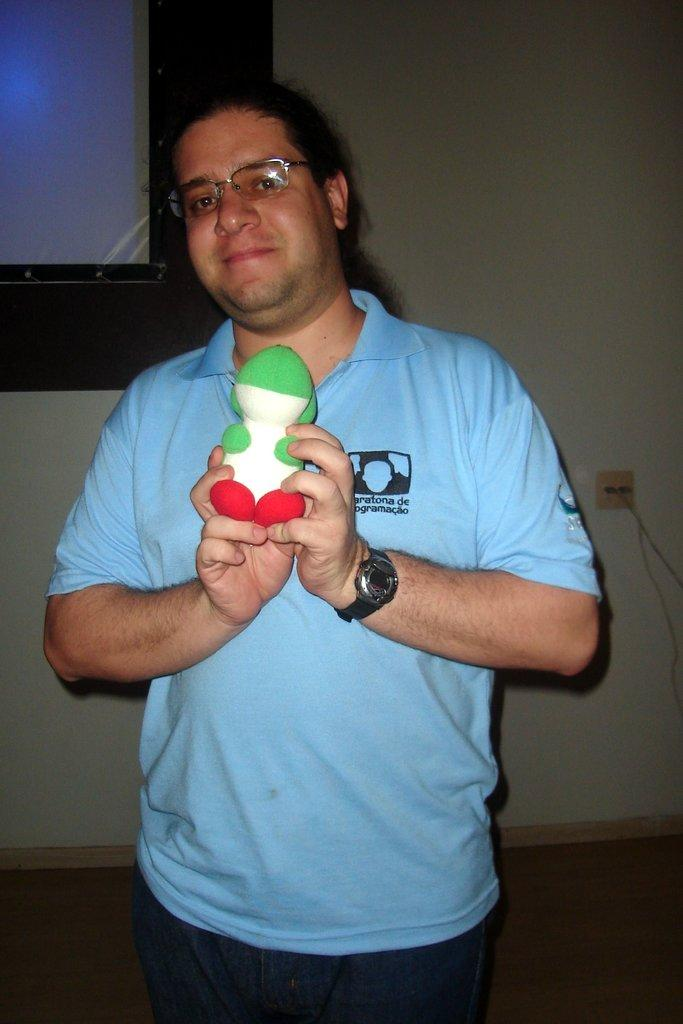Who is present in the image? There is a man in the image. What accessories is the man wearing? The man is wearing glasses and a watch. What is the man holding in the image? The man is holding a toy. What can be seen in the background of the image? There is a wall in the background of the image. What type of whistle can be heard in the image? There is no whistle present in the image, and therefore no sound can be heard. What grade is the man teaching in the image? There is no indication in the image that the man is teaching, nor is there any reference to a grade. 